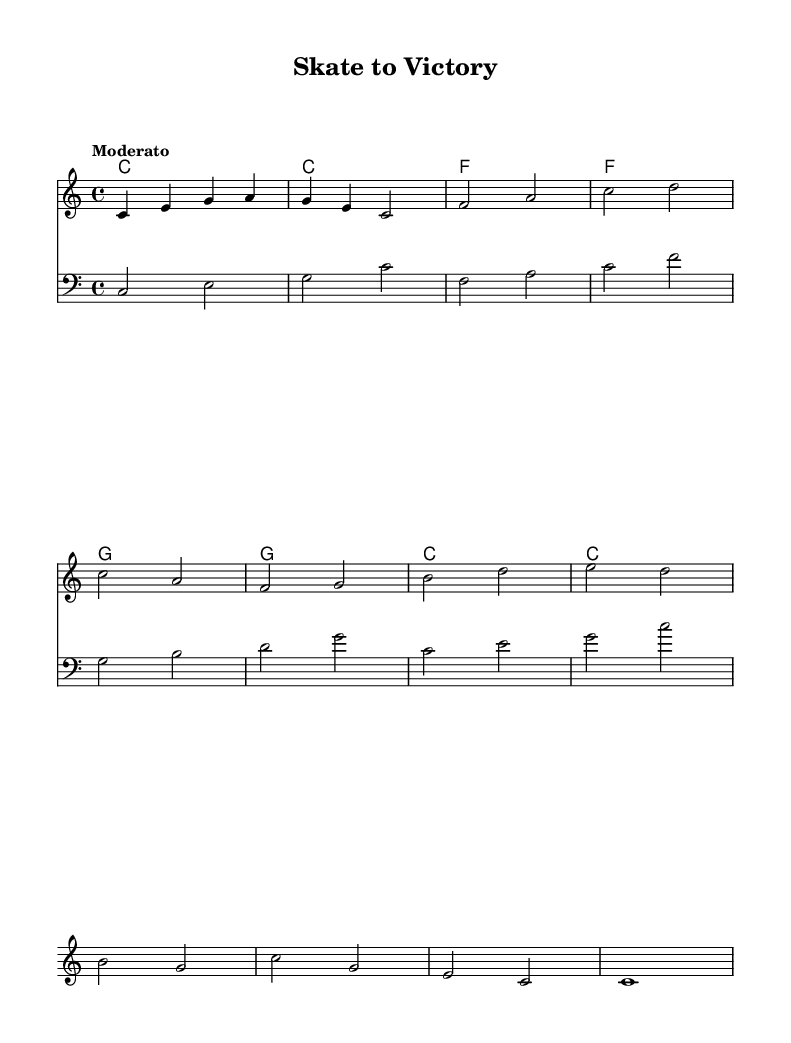What is the key signature of this music? The key signature is C major, which can be identified by the absence of sharps or flats at the beginning of the staff.
Answer: C major What is the time signature of this piece? The time signature is indicated as 4/4 at the beginning of the staff, meaning there are four beats in each measure and a quarter note receives one beat.
Answer: 4/4 What is the tempo marking for this score? The tempo marking "Moderato" is listed above the staff, indicating a moderately paced speed for the performance.
Answer: Moderato How many measures are there in the melody? By counting the number of distinct sets of notes divided by the vertical lines called bar lines, we see there are 8 measures in the melody.
Answer: 8 What is the first note of the melody? The first note is a C, which is the first note indicated on the staff.
Answer: C What chords are used in the harmonies? The chord names listed are C, F, and G, which can be seen written above the staff.
Answer: C, F, G What is the lyrical theme of the song? The lyrics encourage hard work and motivation, reflecting the theme of striving for victory in training.
Answer: Motivation 